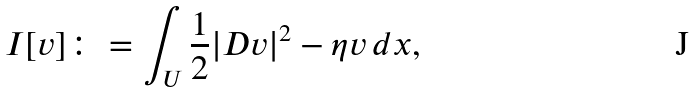<formula> <loc_0><loc_0><loc_500><loc_500>I [ v ] \colon = \int _ { U } \frac { 1 } { 2 } | D v | ^ { 2 } - \eta v \, d x ,</formula> 